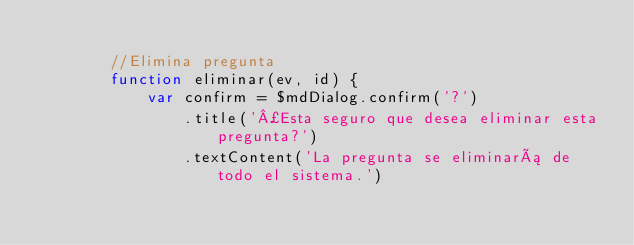<code> <loc_0><loc_0><loc_500><loc_500><_JavaScript_>
        //Elimina pregunta
        function eliminar(ev, id) {
            var confirm = $mdDialog.confirm('?')
                .title('¿Esta seguro que desea eliminar esta pregunta?')
                .textContent('La pregunta se eliminará de todo el sistema.')</code> 